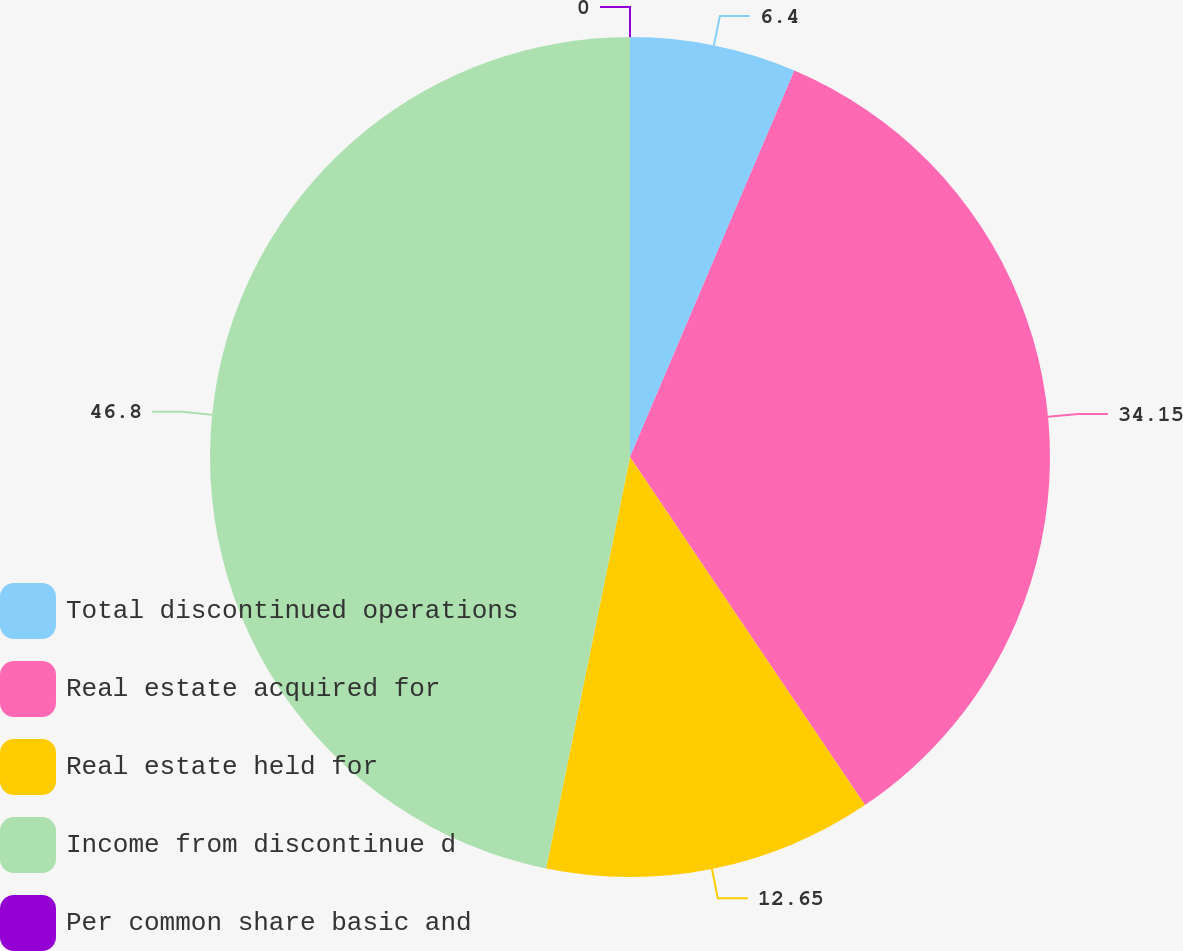<chart> <loc_0><loc_0><loc_500><loc_500><pie_chart><fcel>Total discontinued operations<fcel>Real estate acquired for<fcel>Real estate held for<fcel>Income from discontinue d<fcel>Per common share basic and<nl><fcel>6.4%<fcel>34.15%<fcel>12.65%<fcel>46.8%<fcel>0.0%<nl></chart> 